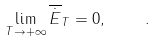Convert formula to latex. <formula><loc_0><loc_0><loc_500><loc_500>\lim _ { T \rightarrow + \infty } \overline { \dot { E } } _ { T } = 0 , \quad .</formula> 